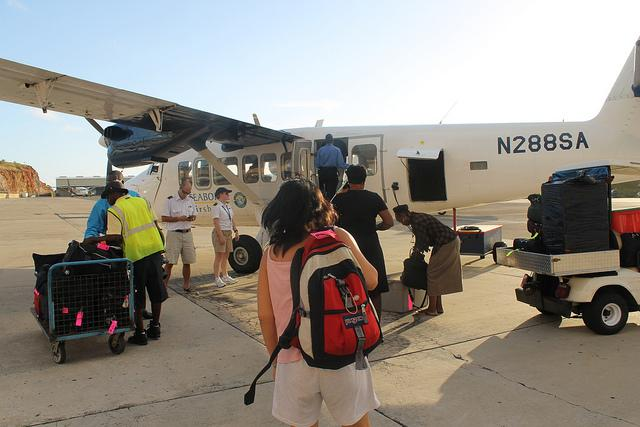Where do the people wearing white shirts work? airport 